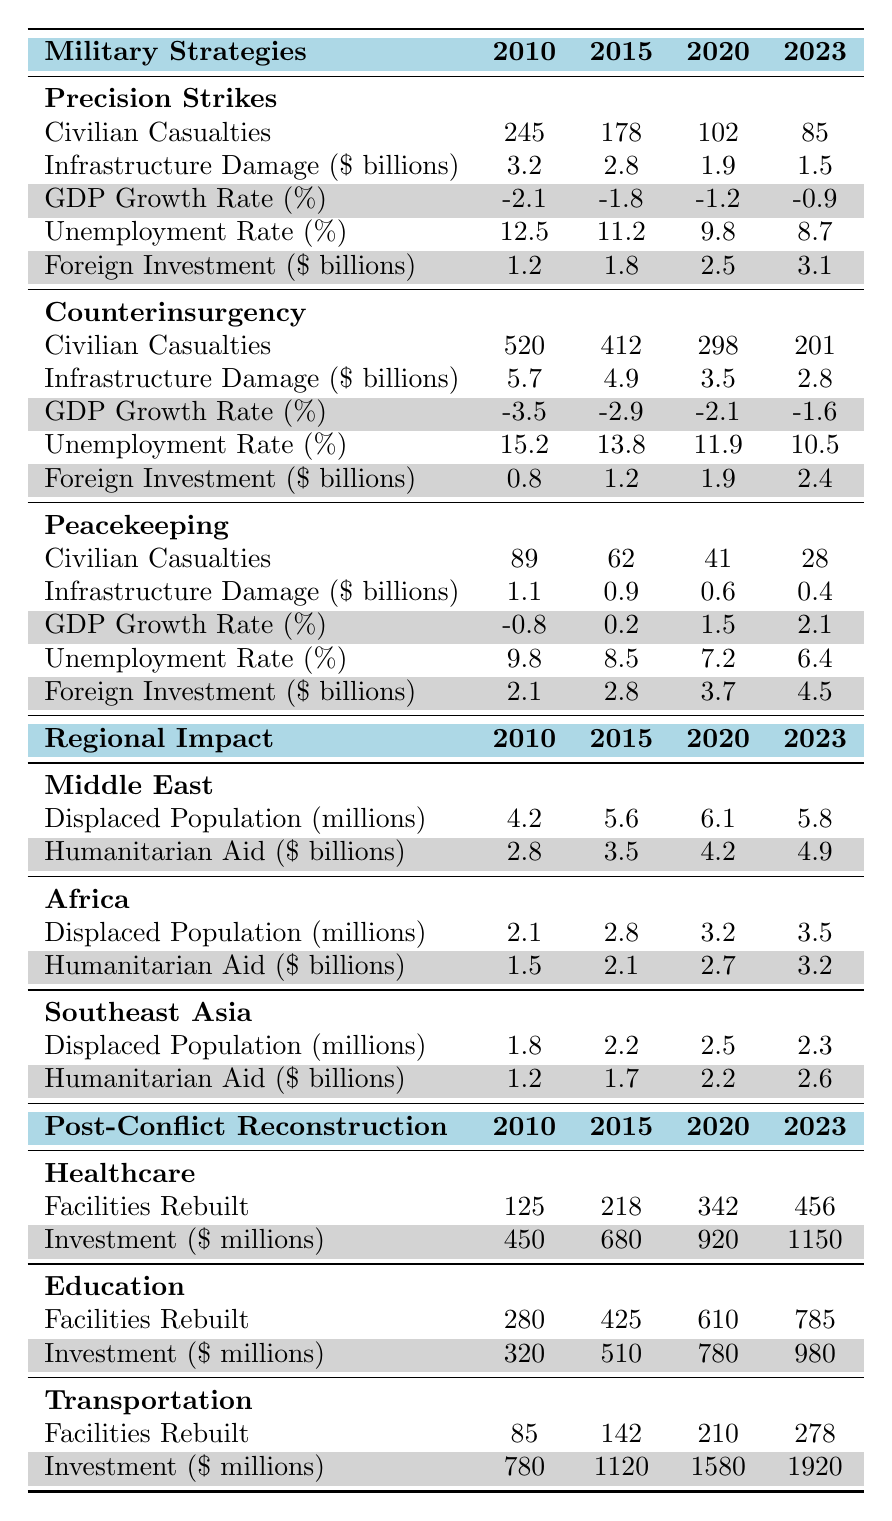What was the civilian casualty count for Counterinsurgency in 2023? The table shows the civilian casualties for Counterinsurgency in 2023, which is listed under the corresponding strategy row. The figure is 201.
Answer: 201 What is the total infrastructure damage caused by Precision Strikes from 2010 to 2023? To find the total infrastructure damage, sum the damage values for Precision Strikes across the years: 3.2 + 2.8 + 1.9 + 1.5 = 9.4 billion dollars.
Answer: 9.4 billion dollars Which strategy had the highest foreign investment in 2023? By comparing the foreign investment values for each strategy in 2023, Precision Strikes had 3.1 billion, Counterinsurgency had 2.4 billion, and Peacekeeping had 4.5 billion. Thus, Peacekeeping had the highest foreign investment.
Answer: Peacekeeping What was the average civilian casualty count for Precision Strikes from 2010 to 2023? The civilian casualty counts for Precision Strikes from 2010 to 2023 are 245, 178, 102, and 85. The average is calculated by summing these numbers (245 + 178 + 102 + 85 = 610) and dividing by 4, which gives 610/4 = 152.5.
Answer: 152.5 What is the trend in GDP growth rate for Counterinsurgency from 2010 to 2023? Looking at the GDP growth rate values for Counterinsurgency from 2010 (-3.5%) to 2023 (-1.6%), the trend shows a gradual improvement (the rates are increasing towards zero).
Answer: Gradual improvement Was there a decrease in unemployment rate for Peacekeeping from 2010 to 2023? The unemployment rates for Peacekeeping from 2010 (9.8%) to 2023 (6.4%) indicate a decrease, as 6.4 is less than 9.8.
Answer: Yes How much humanitarian aid was provided to the Middle East in total from 2010 to 2023? To find the total humanitarian aid for the Middle East from 2010 to 2023, sum the values: 2.8 + 3.5 + 4.2 + 4.9 = 15.4 billion dollars.
Answer: 15.4 billion dollars Which sector saw the highest number of facilities rebuilt by 2023? The sectors are shown with their respective facilities rebuilt: Healthcare (456), Education (785), and Transportation (278). Education has the highest count at 785.
Answer: Education Did the infrastructure damage caused by Peacekeeping decrease from 2010 to 2023? By looking at the infrastructure damage values for Peacekeeping, it went from 1.1 billion in 2010 to 0.4 billion in 2023, showing a decrease.
Answer: Yes What is the percentage decrease in Civilian Casualties for Counterinsurgency from 2010 to 2023? Civilian casualties dropped from 520 in 2010 to 201 in 2023. The decrease is calculated as (520 - 201) = 319, and the percentage decrease is (319 / 520) * 100 = 61.54%.
Answer: 61.54% 